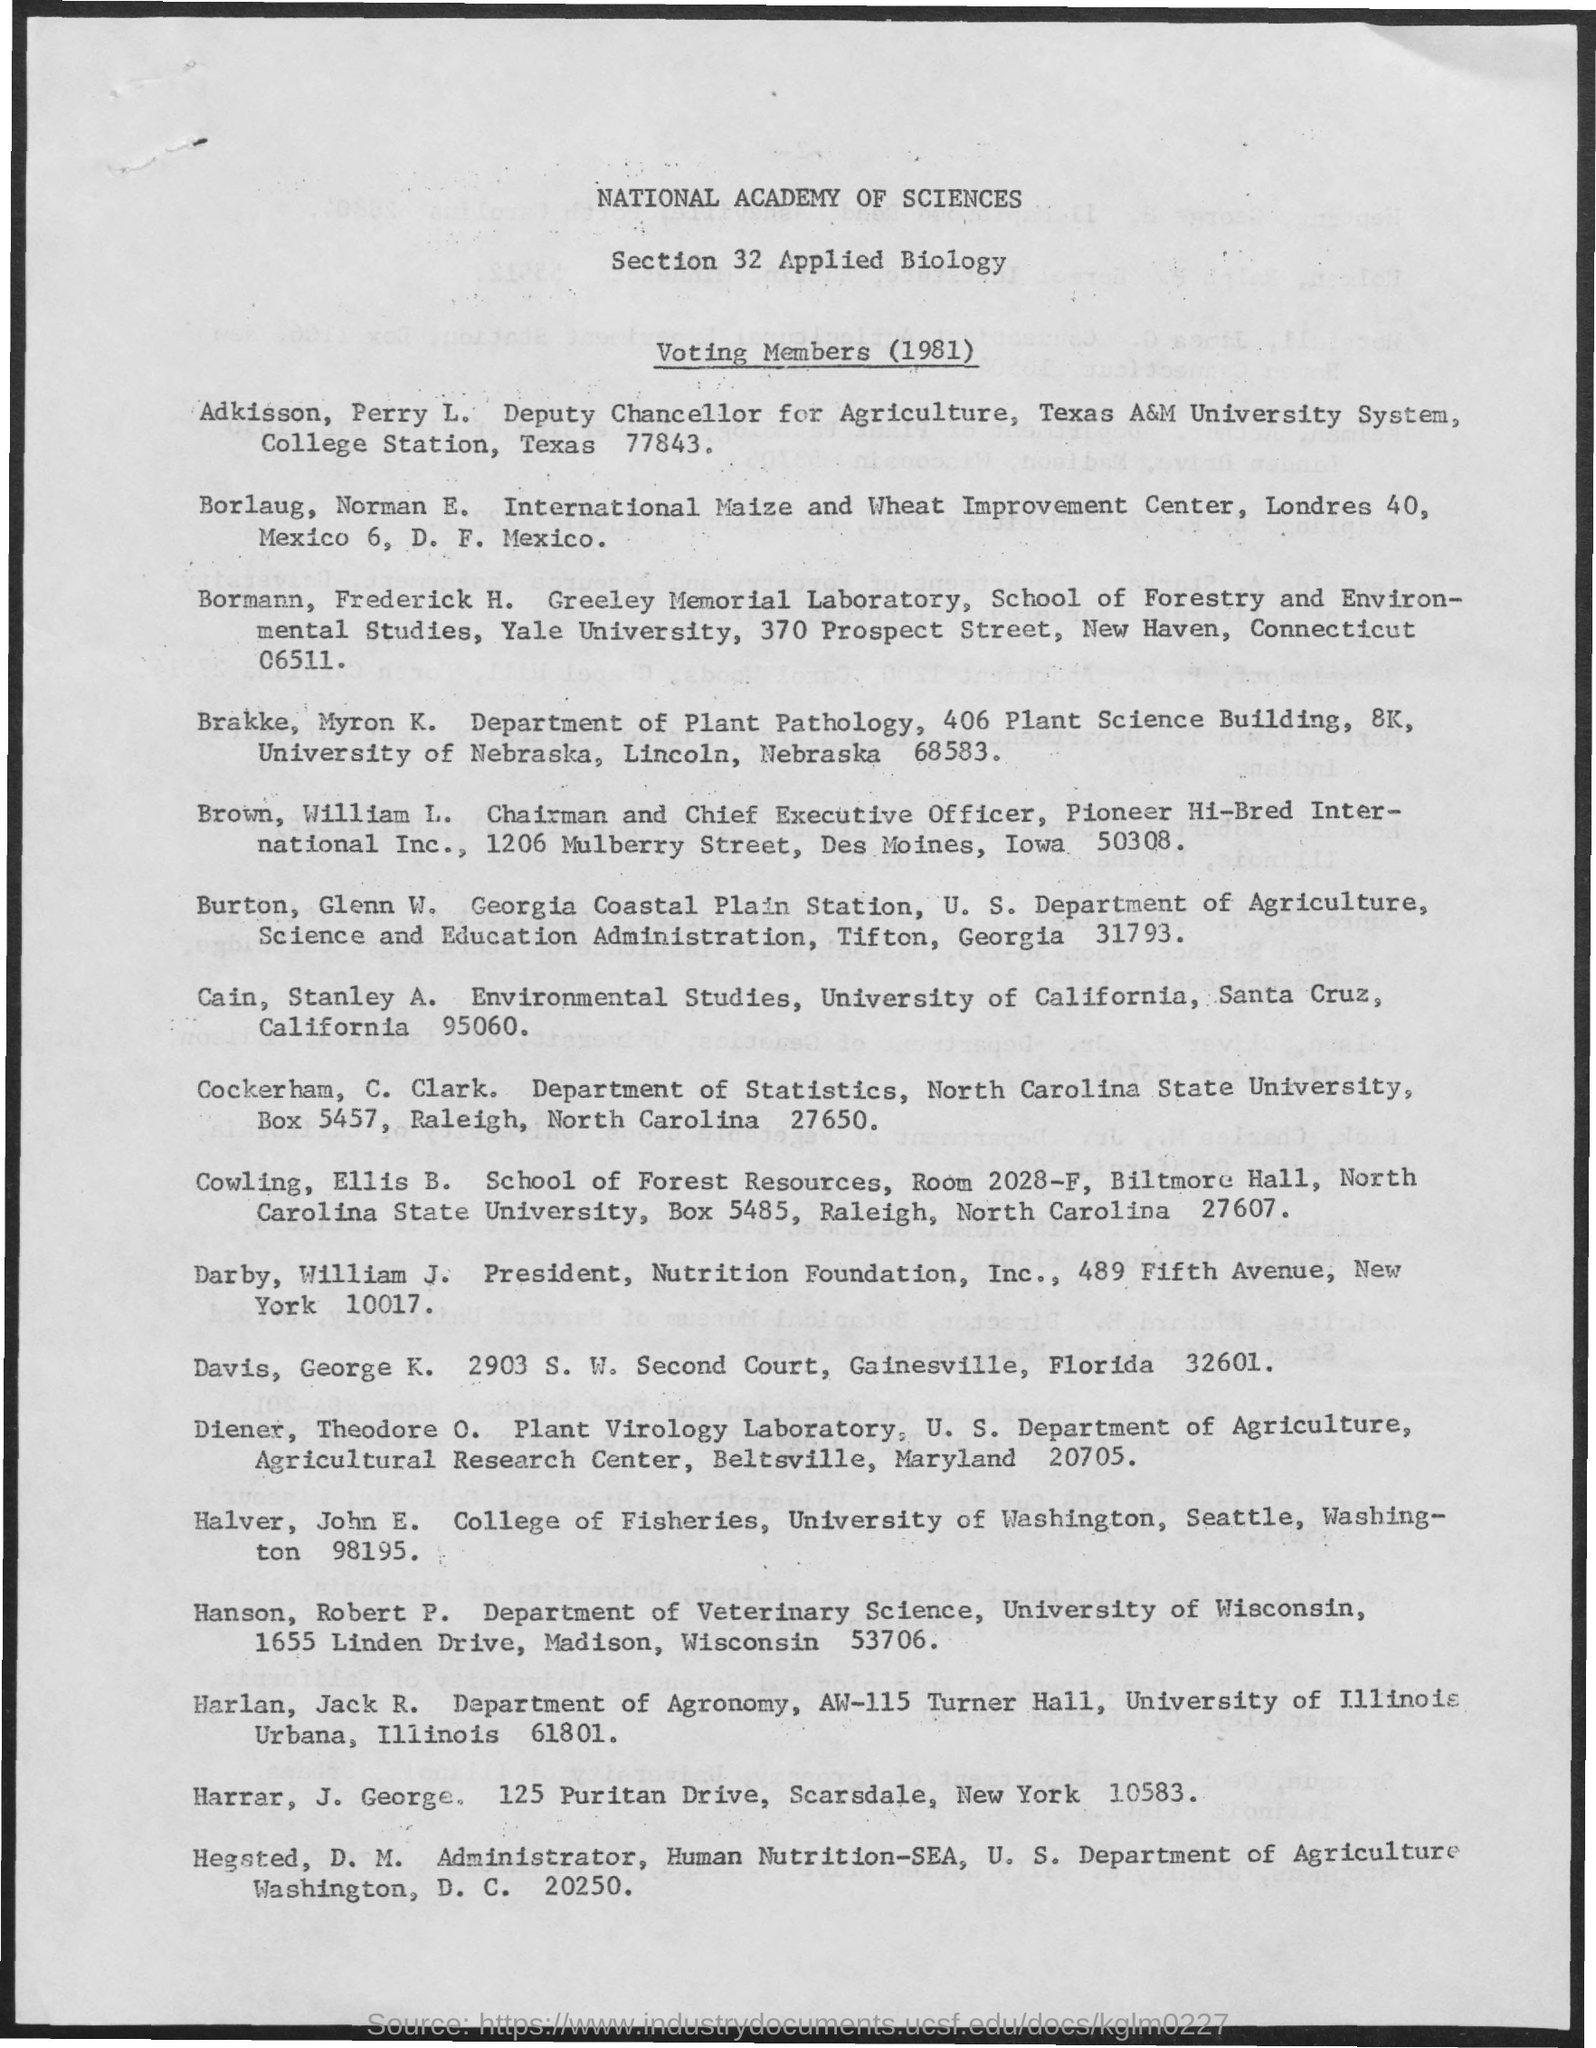Who is Deputy Chancellor of Agriculture?
Give a very brief answer. Adkisson Perry L. Which year's voting members detail it is?
Offer a terse response. 1981. 